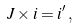Convert formula to latex. <formula><loc_0><loc_0><loc_500><loc_500>J \times i = i ^ { \prime } \, ,</formula> 